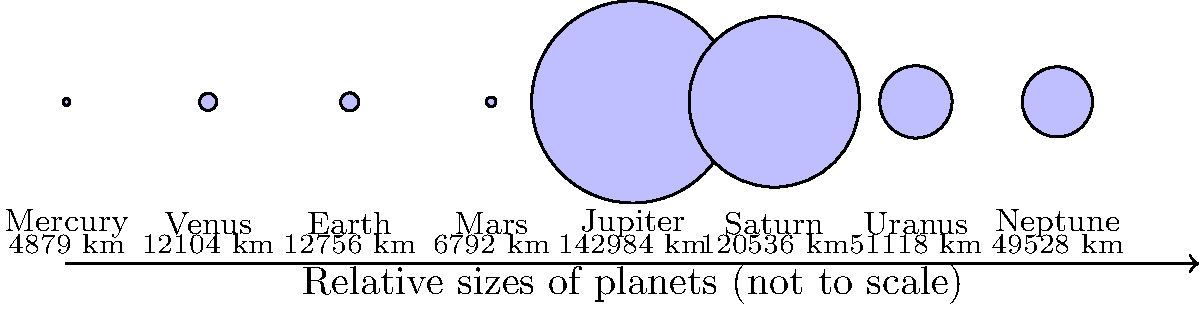Based on the scale comparison chart of planet sizes in our solar system, which planet is approximately 3 times larger in diameter than Earth? Let's approach this step-by-step:

1. First, we need to identify Earth's diameter from the chart. The chart shows Earth's diameter as 12,756 km.

2. Now, we need to find a planet with a diameter approximately 3 times larger than Earth's. To do this, we'll multiply Earth's diameter by 3:

   $12,756 \text{ km} \times 3 = 38,268 \text{ km}$

3. Looking at the chart, we need to find a planet with a diameter close to 38,268 km.

4. Scanning through the planet sizes, we see:
   - Mercury: 4,879 km (too small)
   - Venus: 12,104 km (too small)
   - Mars: 6,792 km (too small)
   - Jupiter: 142,984 km (too large)
   - Saturn: 120,536 km (too large)
   - Uranus: 51,118 km
   - Neptune: 49,528 km

5. Uranus, with a diameter of 51,118 km, is the closest to our calculated value of 38,268 km.

6. To verify:
   $\frac{51,118 \text{ km}}{12,756 \text{ km}} \approx 4$

   So Uranus is actually about 4 times larger than Earth in diameter, which is reasonably close to our target of 3 times larger.
Answer: Uranus 